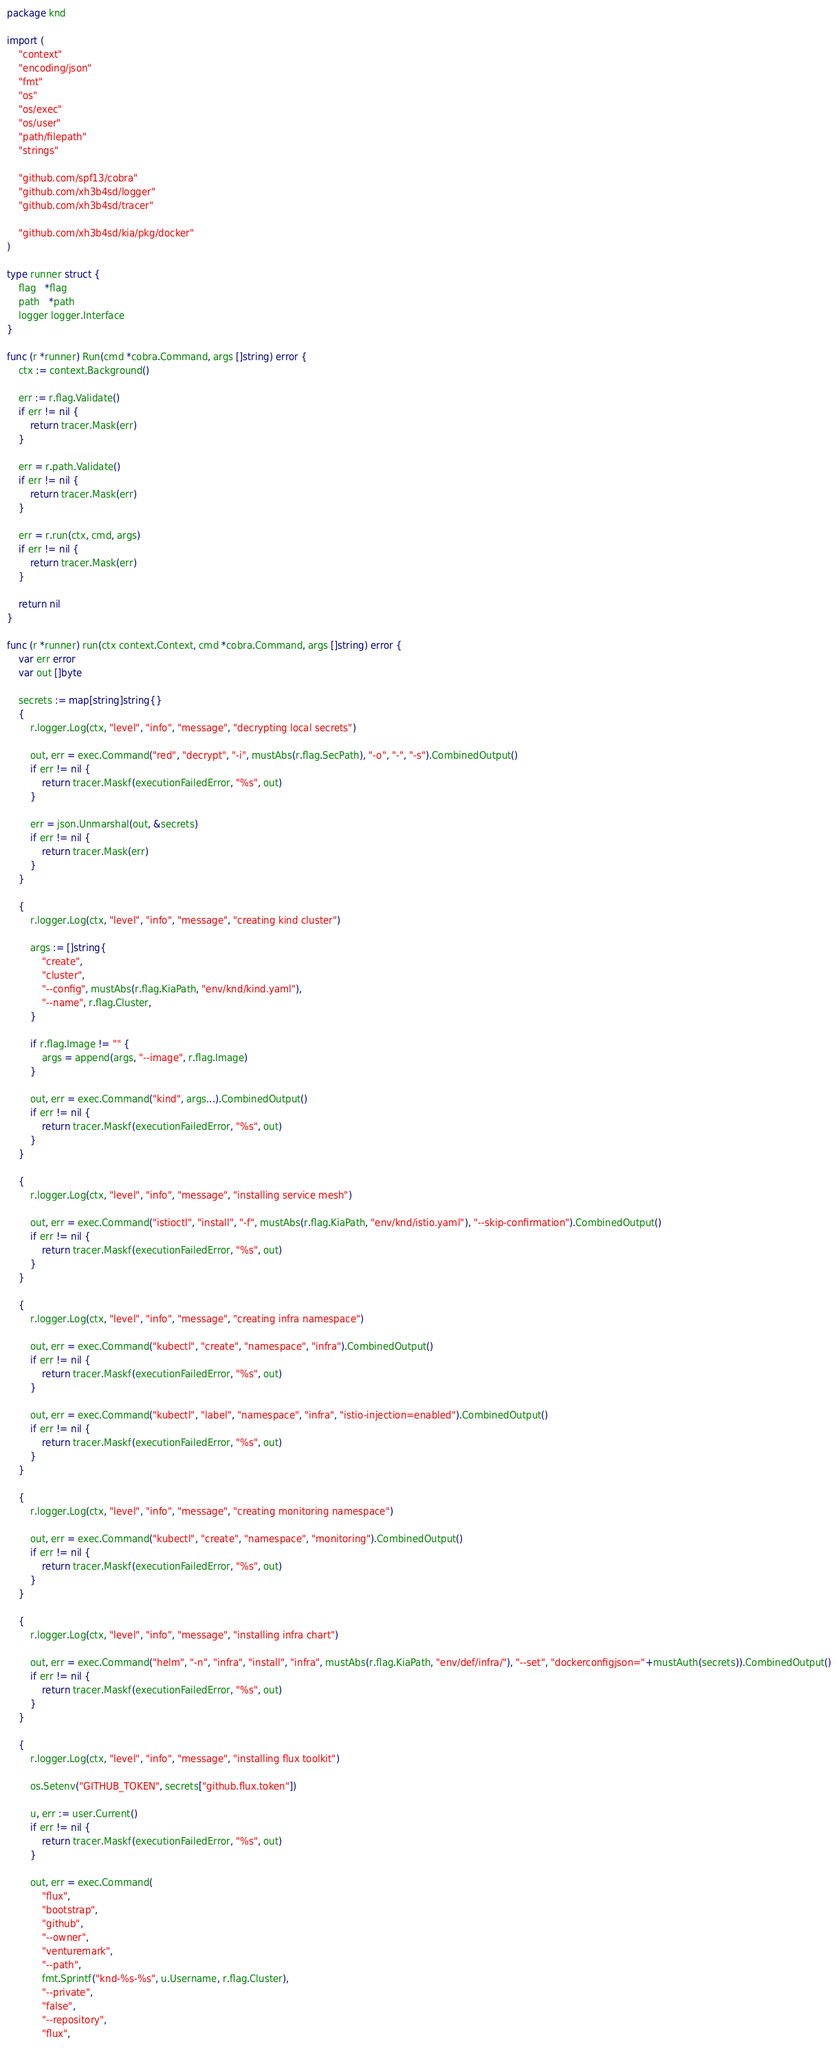<code> <loc_0><loc_0><loc_500><loc_500><_Go_>package knd

import (
	"context"
	"encoding/json"
	"fmt"
	"os"
	"os/exec"
	"os/user"
	"path/filepath"
	"strings"

	"github.com/spf13/cobra"
	"github.com/xh3b4sd/logger"
	"github.com/xh3b4sd/tracer"

	"github.com/xh3b4sd/kia/pkg/docker"
)

type runner struct {
	flag   *flag
	path   *path
	logger logger.Interface
}

func (r *runner) Run(cmd *cobra.Command, args []string) error {
	ctx := context.Background()

	err := r.flag.Validate()
	if err != nil {
		return tracer.Mask(err)
	}

	err = r.path.Validate()
	if err != nil {
		return tracer.Mask(err)
	}

	err = r.run(ctx, cmd, args)
	if err != nil {
		return tracer.Mask(err)
	}

	return nil
}

func (r *runner) run(ctx context.Context, cmd *cobra.Command, args []string) error {
	var err error
	var out []byte

	secrets := map[string]string{}
	{
		r.logger.Log(ctx, "level", "info", "message", "decrypting local secrets")

		out, err = exec.Command("red", "decrypt", "-i", mustAbs(r.flag.SecPath), "-o", "-", "-s").CombinedOutput()
		if err != nil {
			return tracer.Maskf(executionFailedError, "%s", out)
		}

		err = json.Unmarshal(out, &secrets)
		if err != nil {
			return tracer.Mask(err)
		}
	}

	{
		r.logger.Log(ctx, "level", "info", "message", "creating kind cluster")

		args := []string{
			"create",
			"cluster",
			"--config", mustAbs(r.flag.KiaPath, "env/knd/kind.yaml"),
			"--name", r.flag.Cluster,
		}

		if r.flag.Image != "" {
			args = append(args, "--image", r.flag.Image)
		}

		out, err = exec.Command("kind", args...).CombinedOutput()
		if err != nil {
			return tracer.Maskf(executionFailedError, "%s", out)
		}
	}

	{
		r.logger.Log(ctx, "level", "info", "message", "installing service mesh")

		out, err = exec.Command("istioctl", "install", "-f", mustAbs(r.flag.KiaPath, "env/knd/istio.yaml"), "--skip-confirmation").CombinedOutput()
		if err != nil {
			return tracer.Maskf(executionFailedError, "%s", out)
		}
	}

	{
		r.logger.Log(ctx, "level", "info", "message", "creating infra namespace")

		out, err = exec.Command("kubectl", "create", "namespace", "infra").CombinedOutput()
		if err != nil {
			return tracer.Maskf(executionFailedError, "%s", out)
		}

		out, err = exec.Command("kubectl", "label", "namespace", "infra", "istio-injection=enabled").CombinedOutput()
		if err != nil {
			return tracer.Maskf(executionFailedError, "%s", out)
		}
	}

	{
		r.logger.Log(ctx, "level", "info", "message", "creating monitoring namespace")

		out, err = exec.Command("kubectl", "create", "namespace", "monitoring").CombinedOutput()
		if err != nil {
			return tracer.Maskf(executionFailedError, "%s", out)
		}
	}

	{
		r.logger.Log(ctx, "level", "info", "message", "installing infra chart")

		out, err = exec.Command("helm", "-n", "infra", "install", "infra", mustAbs(r.flag.KiaPath, "env/def/infra/"), "--set", "dockerconfigjson="+mustAuth(secrets)).CombinedOutput()
		if err != nil {
			return tracer.Maskf(executionFailedError, "%s", out)
		}
	}

	{
		r.logger.Log(ctx, "level", "info", "message", "installing flux toolkit")

		os.Setenv("GITHUB_TOKEN", secrets["github.flux.token"])

		u, err := user.Current()
		if err != nil {
			return tracer.Maskf(executionFailedError, "%s", out)
		}

		out, err = exec.Command(
			"flux",
			"bootstrap",
			"github",
			"--owner",
			"venturemark",
			"--path",
			fmt.Sprintf("knd-%s-%s", u.Username, r.flag.Cluster),
			"--private",
			"false",
			"--repository",
			"flux",</code> 